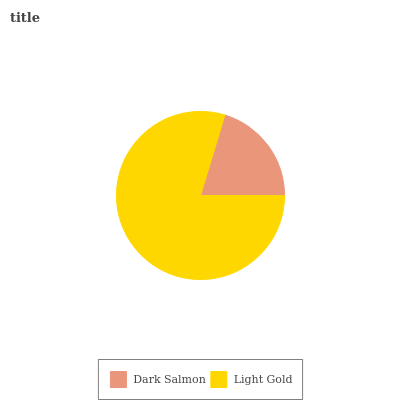Is Dark Salmon the minimum?
Answer yes or no. Yes. Is Light Gold the maximum?
Answer yes or no. Yes. Is Light Gold the minimum?
Answer yes or no. No. Is Light Gold greater than Dark Salmon?
Answer yes or no. Yes. Is Dark Salmon less than Light Gold?
Answer yes or no. Yes. Is Dark Salmon greater than Light Gold?
Answer yes or no. No. Is Light Gold less than Dark Salmon?
Answer yes or no. No. Is Light Gold the high median?
Answer yes or no. Yes. Is Dark Salmon the low median?
Answer yes or no. Yes. Is Dark Salmon the high median?
Answer yes or no. No. Is Light Gold the low median?
Answer yes or no. No. 